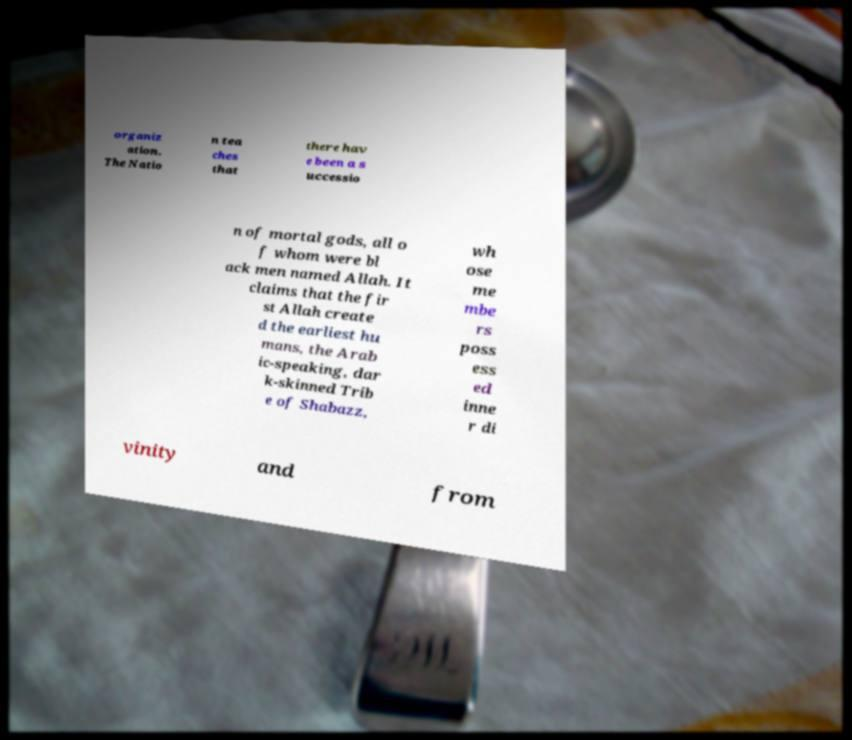Please read and relay the text visible in this image. What does it say? organiz ation. The Natio n tea ches that there hav e been a s uccessio n of mortal gods, all o f whom were bl ack men named Allah. It claims that the fir st Allah create d the earliest hu mans, the Arab ic-speaking, dar k-skinned Trib e of Shabazz, wh ose me mbe rs poss ess ed inne r di vinity and from 